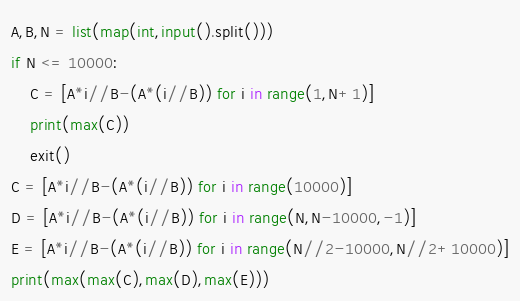<code> <loc_0><loc_0><loc_500><loc_500><_Python_>A,B,N = list(map(int,input().split()))
if N <= 10000:
    C = [A*i//B-(A*(i//B)) for i in range(1,N+1)]
    print(max(C))
    exit()
C = [A*i//B-(A*(i//B)) for i in range(10000)]
D = [A*i//B-(A*(i//B)) for i in range(N,N-10000,-1)]
E = [A*i//B-(A*(i//B)) for i in range(N//2-10000,N//2+10000)]
print(max(max(C),max(D),max(E)))
</code> 